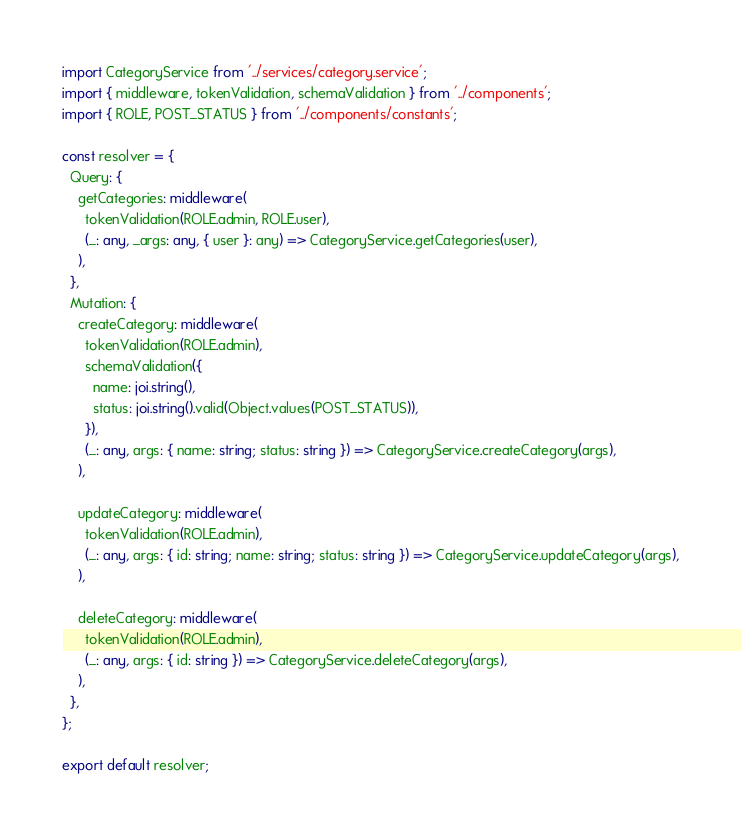Convert code to text. <code><loc_0><loc_0><loc_500><loc_500><_TypeScript_>import CategoryService from '../services/category.service';
import { middleware, tokenValidation, schemaValidation } from '../components';
import { ROLE, POST_STATUS } from '../components/constants';

const resolver = {
  Query: {
    getCategories: middleware(
      tokenValidation(ROLE.admin, ROLE.user),
      (_: any, _args: any, { user }: any) => CategoryService.getCategories(user),
    ),
  },
  Mutation: {
    createCategory: middleware(
      tokenValidation(ROLE.admin),
      schemaValidation({
        name: joi.string(),
        status: joi.string().valid(Object.values(POST_STATUS)),
      }),
      (_: any, args: { name: string; status: string }) => CategoryService.createCategory(args),
    ),

    updateCategory: middleware(
      tokenValidation(ROLE.admin),
      (_: any, args: { id: string; name: string; status: string }) => CategoryService.updateCategory(args),
    ),

    deleteCategory: middleware(
      tokenValidation(ROLE.admin),
      (_: any, args: { id: string }) => CategoryService.deleteCategory(args),
    ),
  },
};

export default resolver;
</code> 